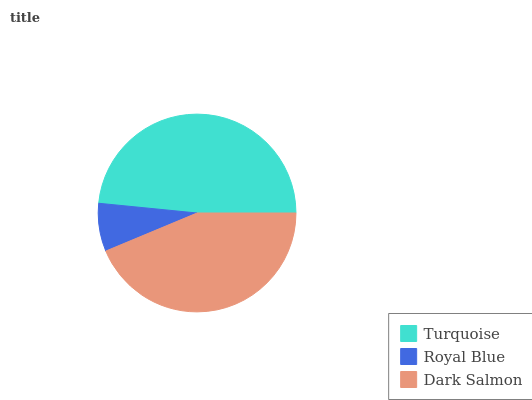Is Royal Blue the minimum?
Answer yes or no. Yes. Is Turquoise the maximum?
Answer yes or no. Yes. Is Dark Salmon the minimum?
Answer yes or no. No. Is Dark Salmon the maximum?
Answer yes or no. No. Is Dark Salmon greater than Royal Blue?
Answer yes or no. Yes. Is Royal Blue less than Dark Salmon?
Answer yes or no. Yes. Is Royal Blue greater than Dark Salmon?
Answer yes or no. No. Is Dark Salmon less than Royal Blue?
Answer yes or no. No. Is Dark Salmon the high median?
Answer yes or no. Yes. Is Dark Salmon the low median?
Answer yes or no. Yes. Is Turquoise the high median?
Answer yes or no. No. Is Royal Blue the low median?
Answer yes or no. No. 